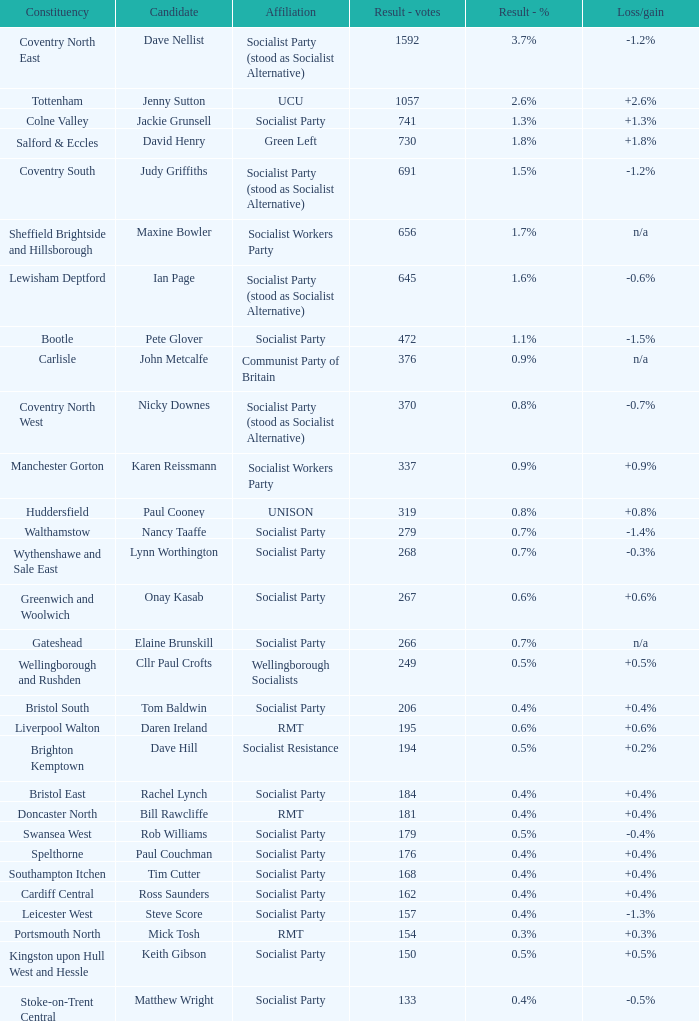Parse the full table. {'header': ['Constituency', 'Candidate', 'Affiliation', 'Result - votes', 'Result - %', 'Loss/gain'], 'rows': [['Coventry North East', 'Dave Nellist', 'Socialist Party (stood as Socialist Alternative)', '1592', '3.7%', '-1.2%'], ['Tottenham', 'Jenny Sutton', 'UCU', '1057', '2.6%', '+2.6%'], ['Colne Valley', 'Jackie Grunsell', 'Socialist Party', '741', '1.3%', '+1.3%'], ['Salford & Eccles', 'David Henry', 'Green Left', '730', '1.8%', '+1.8%'], ['Coventry South', 'Judy Griffiths', 'Socialist Party (stood as Socialist Alternative)', '691', '1.5%', '-1.2%'], ['Sheffield Brightside and Hillsborough', 'Maxine Bowler', 'Socialist Workers Party', '656', '1.7%', 'n/a'], ['Lewisham Deptford', 'Ian Page', 'Socialist Party (stood as Socialist Alternative)', '645', '1.6%', '-0.6%'], ['Bootle', 'Pete Glover', 'Socialist Party', '472', '1.1%', '-1.5%'], ['Carlisle', 'John Metcalfe', 'Communist Party of Britain', '376', '0.9%', 'n/a'], ['Coventry North West', 'Nicky Downes', 'Socialist Party (stood as Socialist Alternative)', '370', '0.8%', '-0.7%'], ['Manchester Gorton', 'Karen Reissmann', 'Socialist Workers Party', '337', '0.9%', '+0.9%'], ['Huddersfield', 'Paul Cooney', 'UNISON', '319', '0.8%', '+0.8%'], ['Walthamstow', 'Nancy Taaffe', 'Socialist Party', '279', '0.7%', '-1.4%'], ['Wythenshawe and Sale East', 'Lynn Worthington', 'Socialist Party', '268', '0.7%', '-0.3%'], ['Greenwich and Woolwich', 'Onay Kasab', 'Socialist Party', '267', '0.6%', '+0.6%'], ['Gateshead', 'Elaine Brunskill', 'Socialist Party', '266', '0.7%', 'n/a'], ['Wellingborough and Rushden', 'Cllr Paul Crofts', 'Wellingborough Socialists', '249', '0.5%', '+0.5%'], ['Bristol South', 'Tom Baldwin', 'Socialist Party', '206', '0.4%', '+0.4%'], ['Liverpool Walton', 'Daren Ireland', 'RMT', '195', '0.6%', '+0.6%'], ['Brighton Kemptown', 'Dave Hill', 'Socialist Resistance', '194', '0.5%', '+0.2%'], ['Bristol East', 'Rachel Lynch', 'Socialist Party', '184', '0.4%', '+0.4%'], ['Doncaster North', 'Bill Rawcliffe', 'RMT', '181', '0.4%', '+0.4%'], ['Swansea West', 'Rob Williams', 'Socialist Party', '179', '0.5%', '-0.4%'], ['Spelthorne', 'Paul Couchman', 'Socialist Party', '176', '0.4%', '+0.4%'], ['Southampton Itchen', 'Tim Cutter', 'Socialist Party', '168', '0.4%', '+0.4%'], ['Cardiff Central', 'Ross Saunders', 'Socialist Party', '162', '0.4%', '+0.4%'], ['Leicester West', 'Steve Score', 'Socialist Party', '157', '0.4%', '-1.3%'], ['Portsmouth North', 'Mick Tosh', 'RMT', '154', '0.3%', '+0.3%'], ['Kingston upon Hull West and Hessle', 'Keith Gibson', 'Socialist Party', '150', '0.5%', '+0.5%'], ['Stoke-on-Trent Central', 'Matthew Wright', 'Socialist Party', '133', '0.4%', '-0.5%']]} What is every candidate for the Cardiff Central constituency? Ross Saunders. 